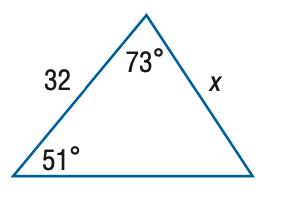Question: Find x. Round side measure to the nearest tenth.
Choices:
A. 26.0
B. 30.0
C. 34.1
D. 39.4
Answer with the letter. Answer: B 